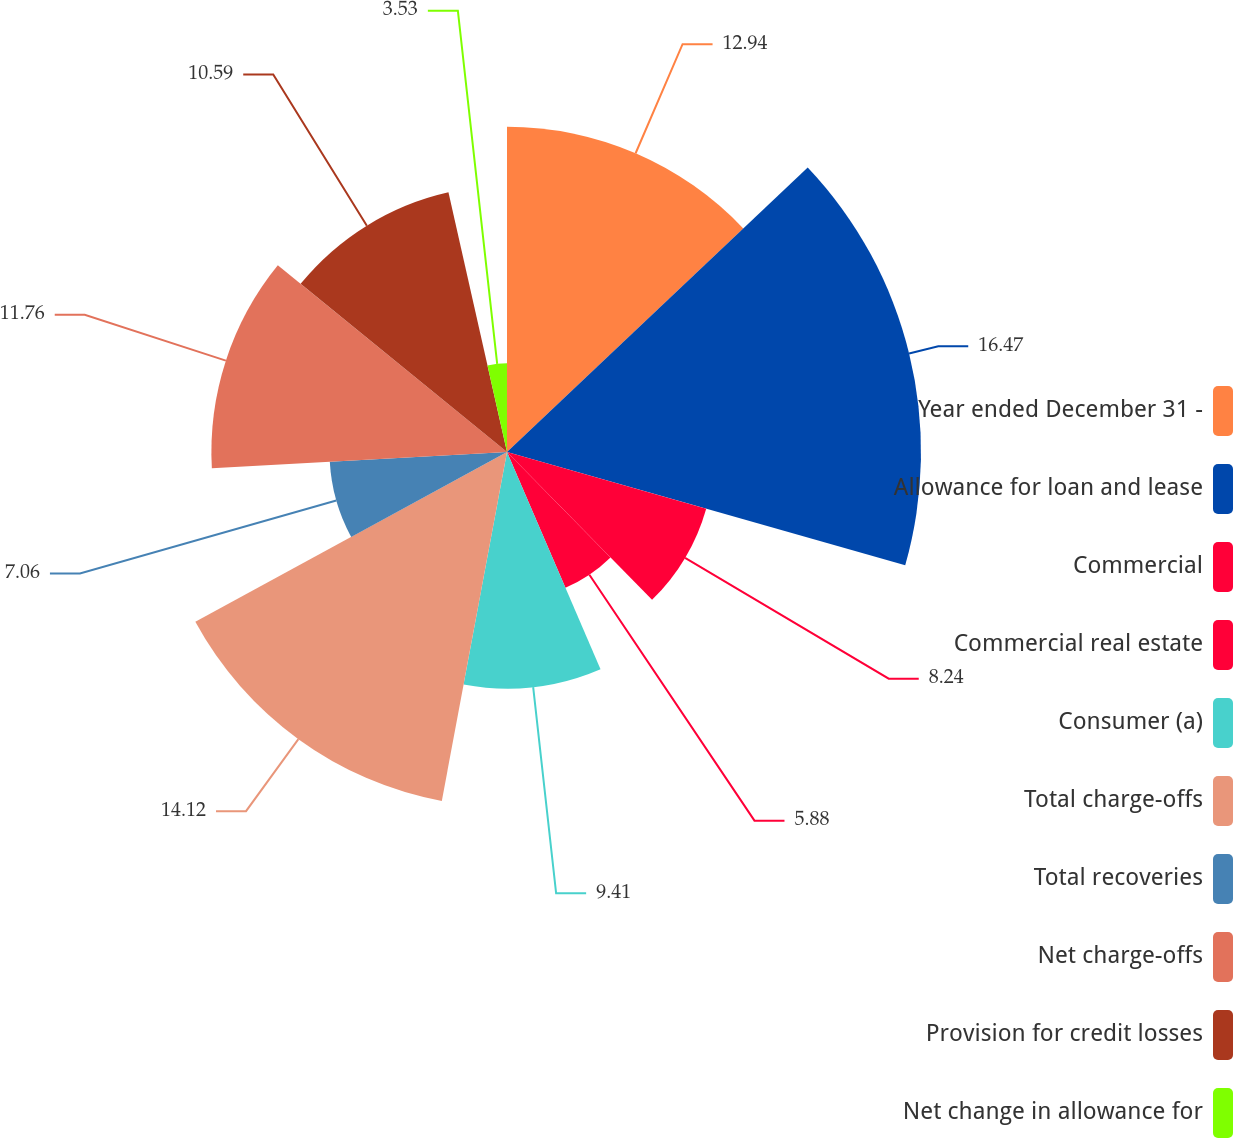Convert chart to OTSL. <chart><loc_0><loc_0><loc_500><loc_500><pie_chart><fcel>Year ended December 31 -<fcel>Allowance for loan and lease<fcel>Commercial<fcel>Commercial real estate<fcel>Consumer (a)<fcel>Total charge-offs<fcel>Total recoveries<fcel>Net charge-offs<fcel>Provision for credit losses<fcel>Net change in allowance for<nl><fcel>12.94%<fcel>16.47%<fcel>8.24%<fcel>5.88%<fcel>9.41%<fcel>14.12%<fcel>7.06%<fcel>11.76%<fcel>10.59%<fcel>3.53%<nl></chart> 